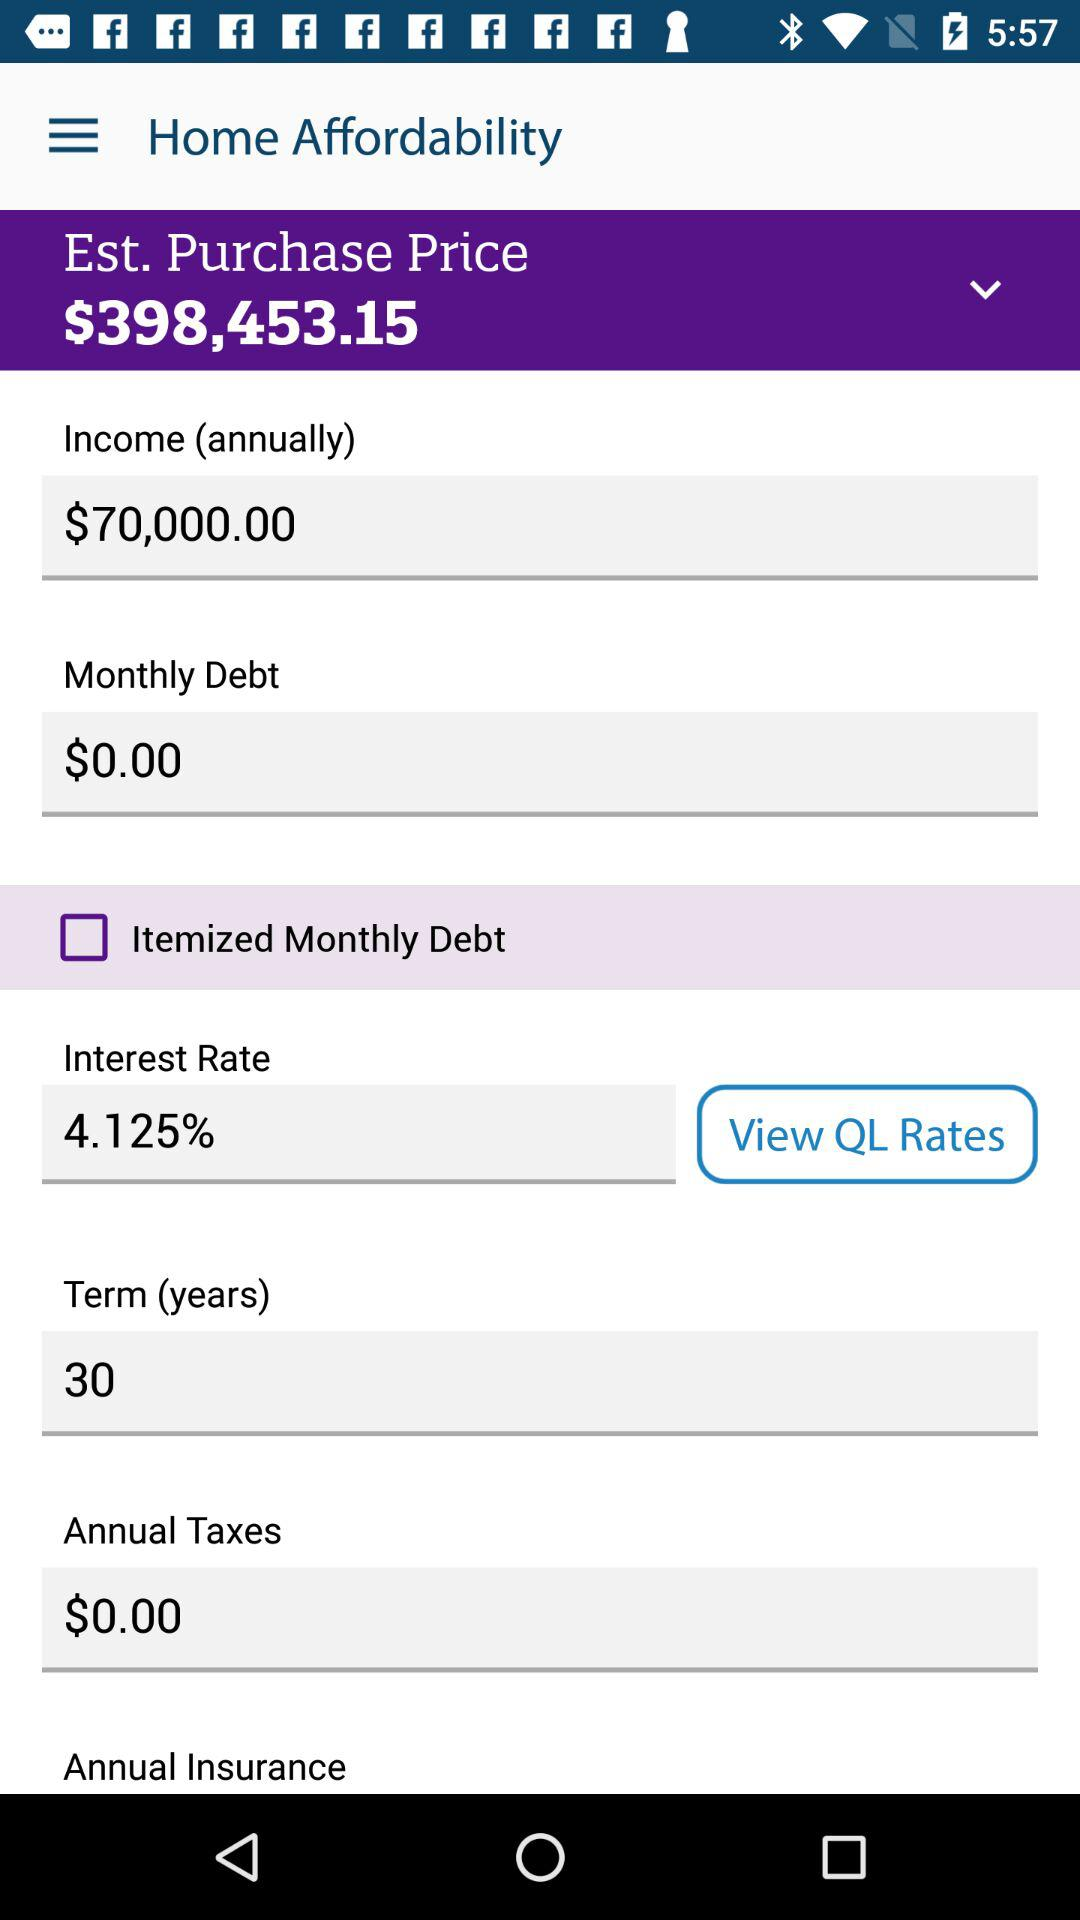What is the interest rate? The interest rate is 4.125%. 